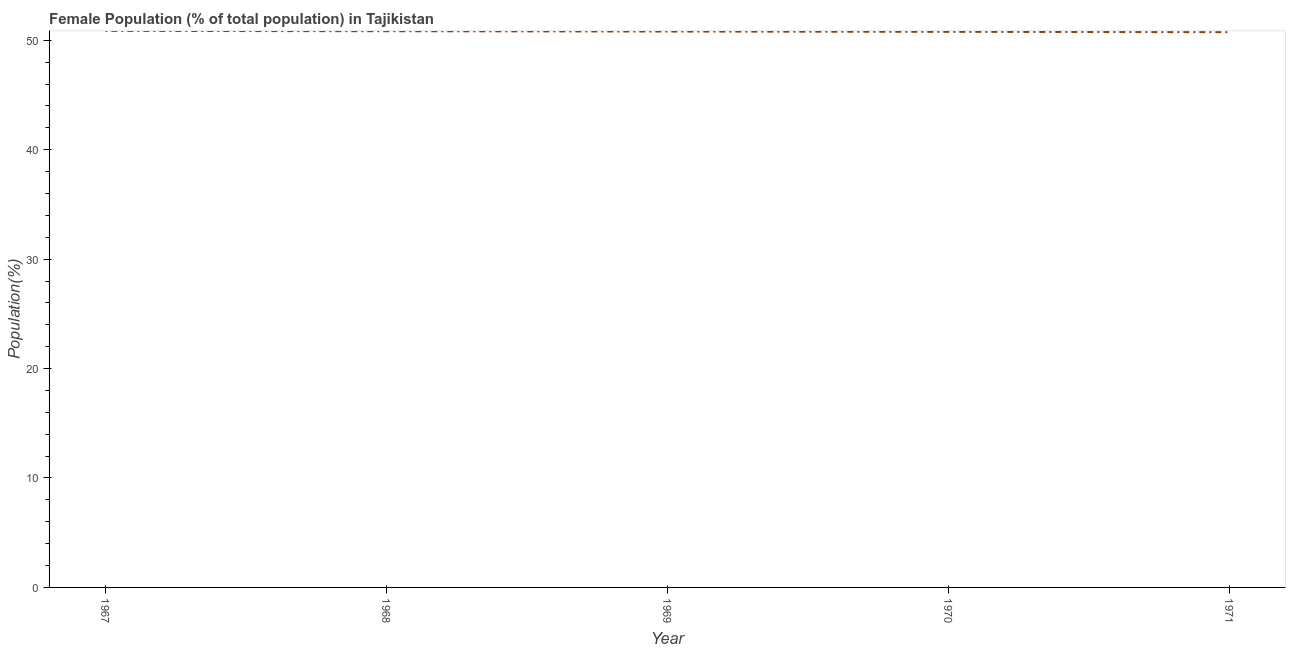What is the female population in 1967?
Offer a terse response. 50.86. Across all years, what is the maximum female population?
Offer a terse response. 50.86. Across all years, what is the minimum female population?
Provide a succinct answer. 50.74. In which year was the female population maximum?
Keep it short and to the point. 1967. What is the sum of the female population?
Your answer should be compact. 253.99. What is the difference between the female population in 1967 and 1970?
Provide a succinct answer. 0.09. What is the average female population per year?
Offer a terse response. 50.8. What is the median female population?
Your answer should be very brief. 50.8. In how many years, is the female population greater than 44 %?
Your answer should be compact. 5. Do a majority of the years between 1968 and 1970 (inclusive) have female population greater than 6 %?
Provide a succinct answer. Yes. What is the ratio of the female population in 1967 to that in 1971?
Offer a terse response. 1. Is the female population in 1968 less than that in 1970?
Ensure brevity in your answer.  No. Is the difference between the female population in 1967 and 1970 greater than the difference between any two years?
Your response must be concise. No. What is the difference between the highest and the second highest female population?
Give a very brief answer. 0.03. What is the difference between the highest and the lowest female population?
Keep it short and to the point. 0.12. Does the graph contain grids?
Your response must be concise. No. What is the title of the graph?
Offer a terse response. Female Population (% of total population) in Tajikistan. What is the label or title of the X-axis?
Your answer should be compact. Year. What is the label or title of the Y-axis?
Keep it short and to the point. Population(%). What is the Population(%) of 1967?
Your answer should be compact. 50.86. What is the Population(%) of 1968?
Ensure brevity in your answer.  50.83. What is the Population(%) in 1969?
Give a very brief answer. 50.8. What is the Population(%) of 1970?
Keep it short and to the point. 50.77. What is the Population(%) of 1971?
Provide a succinct answer. 50.74. What is the difference between the Population(%) in 1967 and 1968?
Keep it short and to the point. 0.03. What is the difference between the Population(%) in 1967 and 1969?
Your response must be concise. 0.06. What is the difference between the Population(%) in 1967 and 1970?
Your response must be concise. 0.09. What is the difference between the Population(%) in 1967 and 1971?
Your answer should be very brief. 0.12. What is the difference between the Population(%) in 1968 and 1969?
Keep it short and to the point. 0.03. What is the difference between the Population(%) in 1968 and 1970?
Give a very brief answer. 0.06. What is the difference between the Population(%) in 1968 and 1971?
Your answer should be very brief. 0.09. What is the difference between the Population(%) in 1969 and 1970?
Your answer should be compact. 0.03. What is the difference between the Population(%) in 1969 and 1971?
Your answer should be very brief. 0.06. What is the difference between the Population(%) in 1970 and 1971?
Your answer should be compact. 0.03. What is the ratio of the Population(%) in 1968 to that in 1969?
Provide a succinct answer. 1. What is the ratio of the Population(%) in 1969 to that in 1971?
Ensure brevity in your answer.  1. What is the ratio of the Population(%) in 1970 to that in 1971?
Offer a very short reply. 1. 